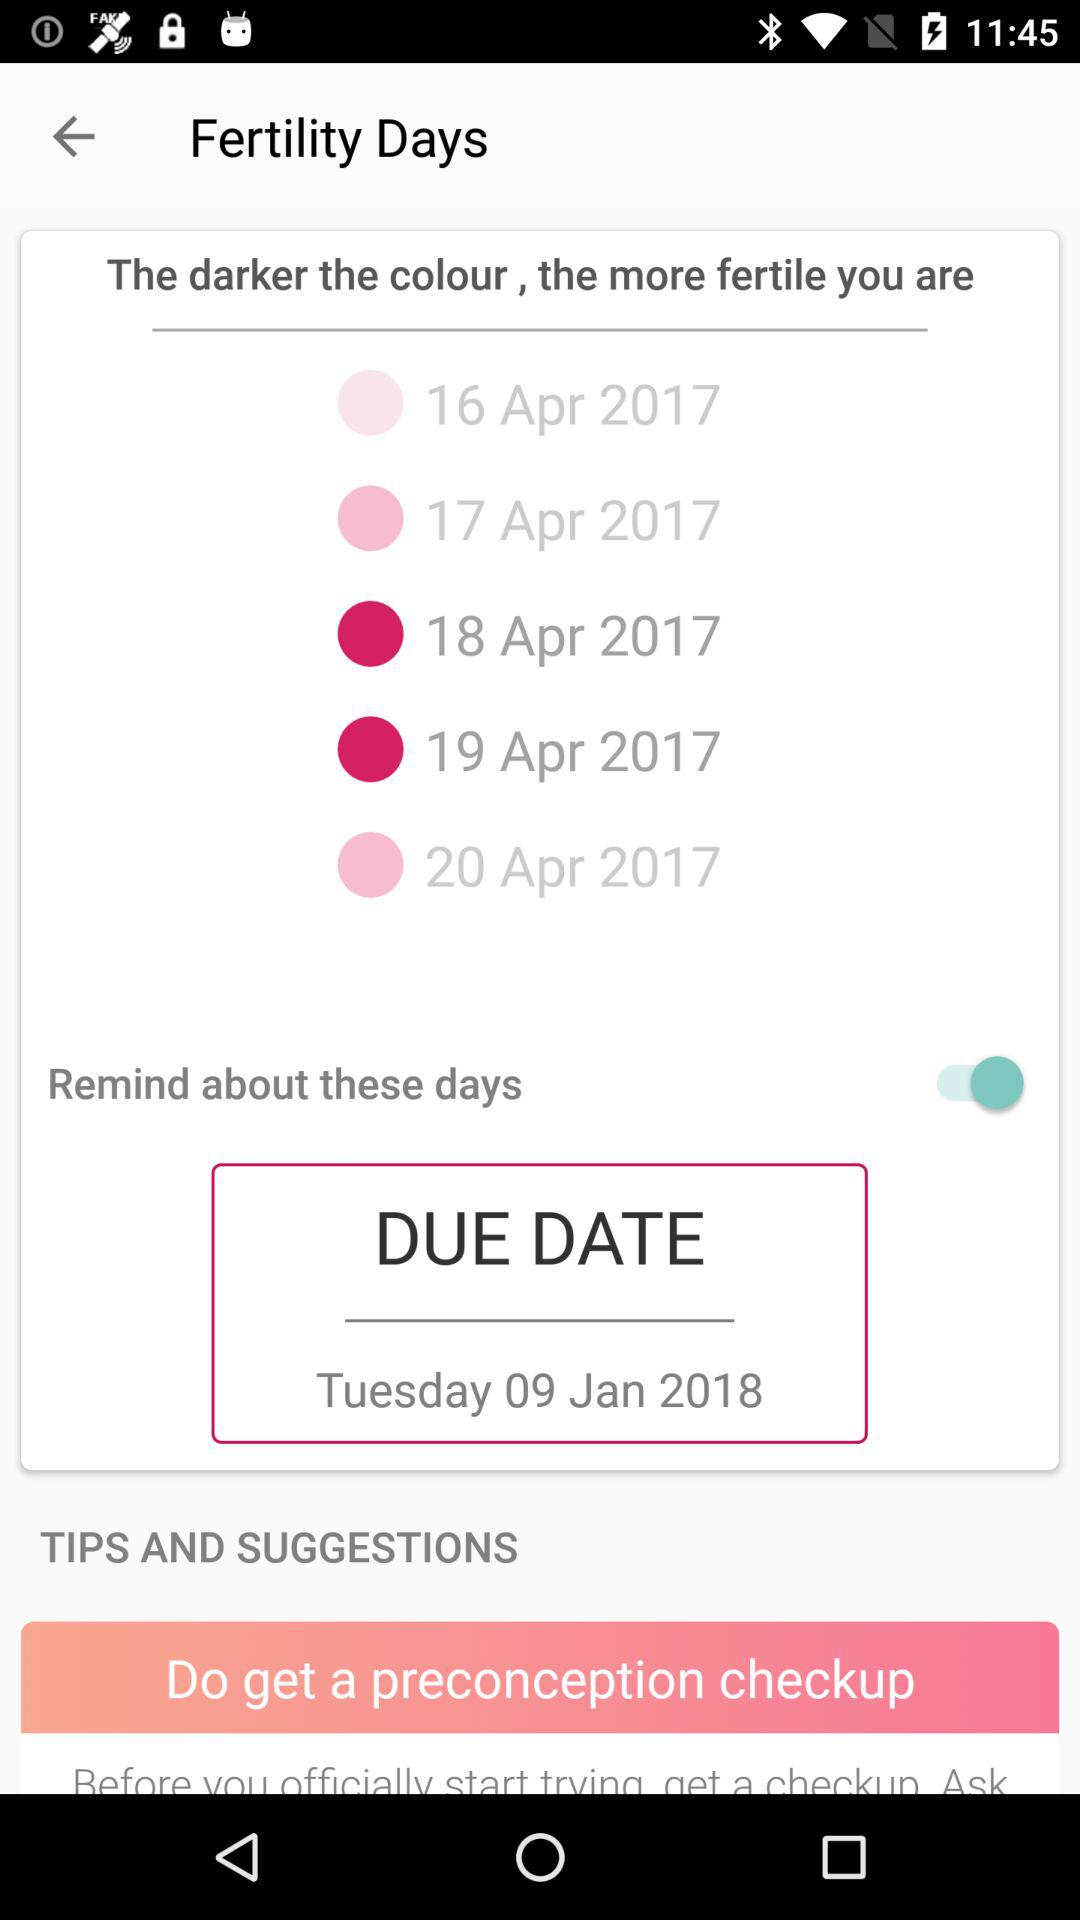What is the due date? The due date is Tuesday, January 9, 2018. 